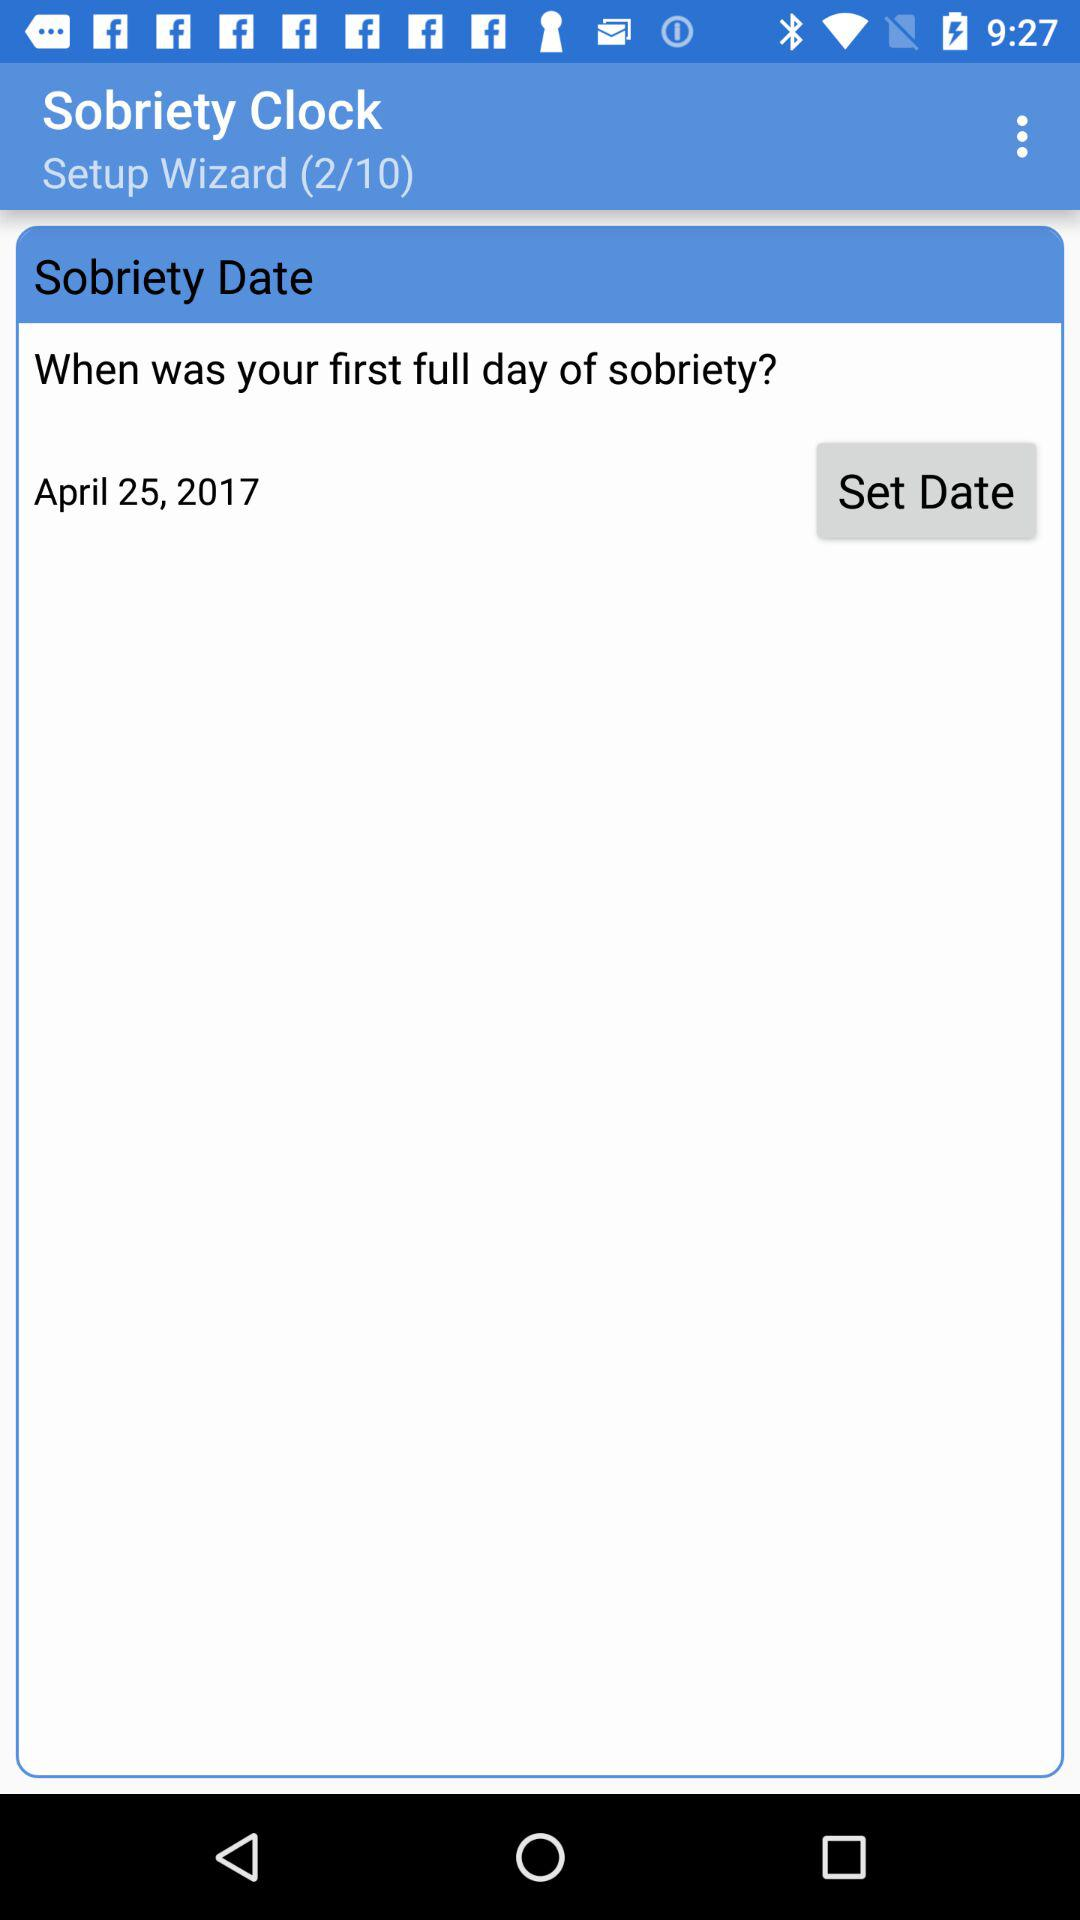What's the total number of processes in the setup wizard? The total number of processes is 10. 